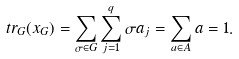<formula> <loc_0><loc_0><loc_500><loc_500>t r _ { G } ( x _ { G } ) = \sum _ { \sigma \in G } { \sum _ { j = 1 } ^ { q } { \sigma a _ { j } } } = \sum _ { a \in A } { a } = 1 .</formula> 